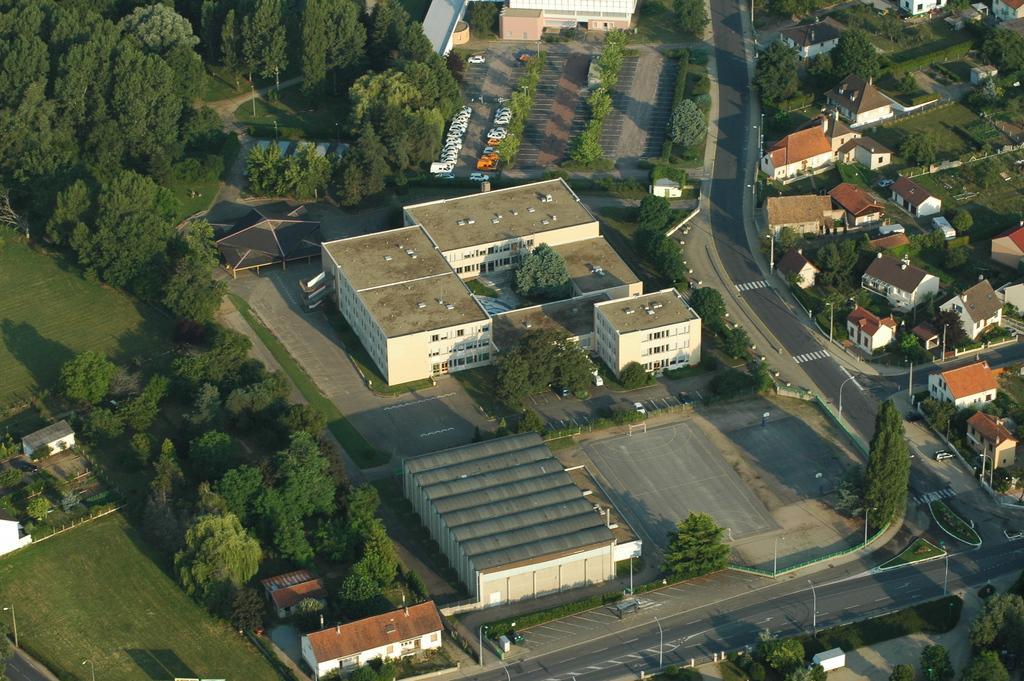How would you summarize this image in a sentence or two? In this image I see number of buildings and houses and I see the path, poles, green grass and I see number of trees. 